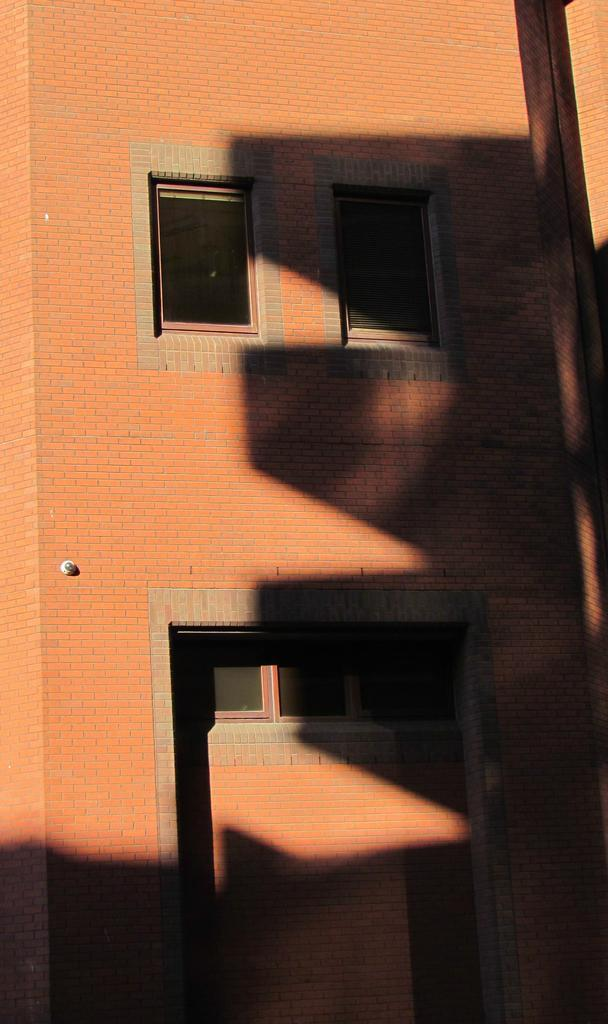What type of structure is visible in the image? There is a building in the image. What feature can be seen on the building? The building has windows. Is there anything else on the building besides windows? Yes, there is an object on the building. What color is the grape hanging from the zipper on the tent in the image? There is no grape, zipper, or tent present in the image. 